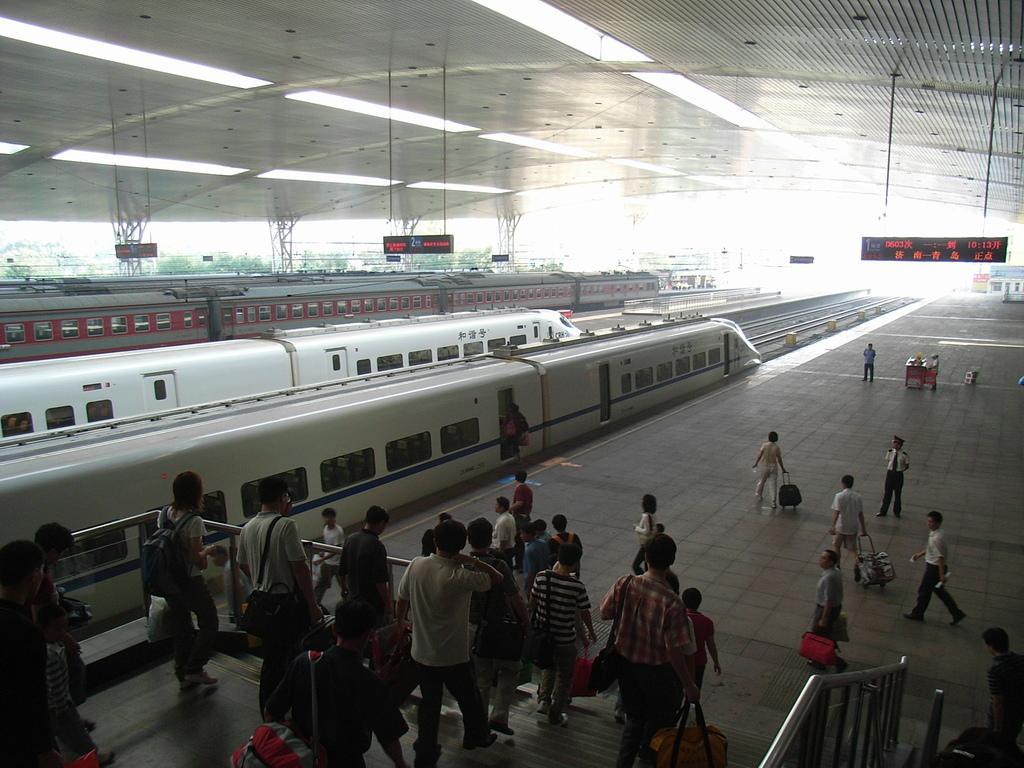Describe this image in one or two sentences. In this image in front there are people walking on the stairs. There are railings. There are people standing on the platform. In the center of the image there are trains. There are display boards. On top of the image there are lights. 